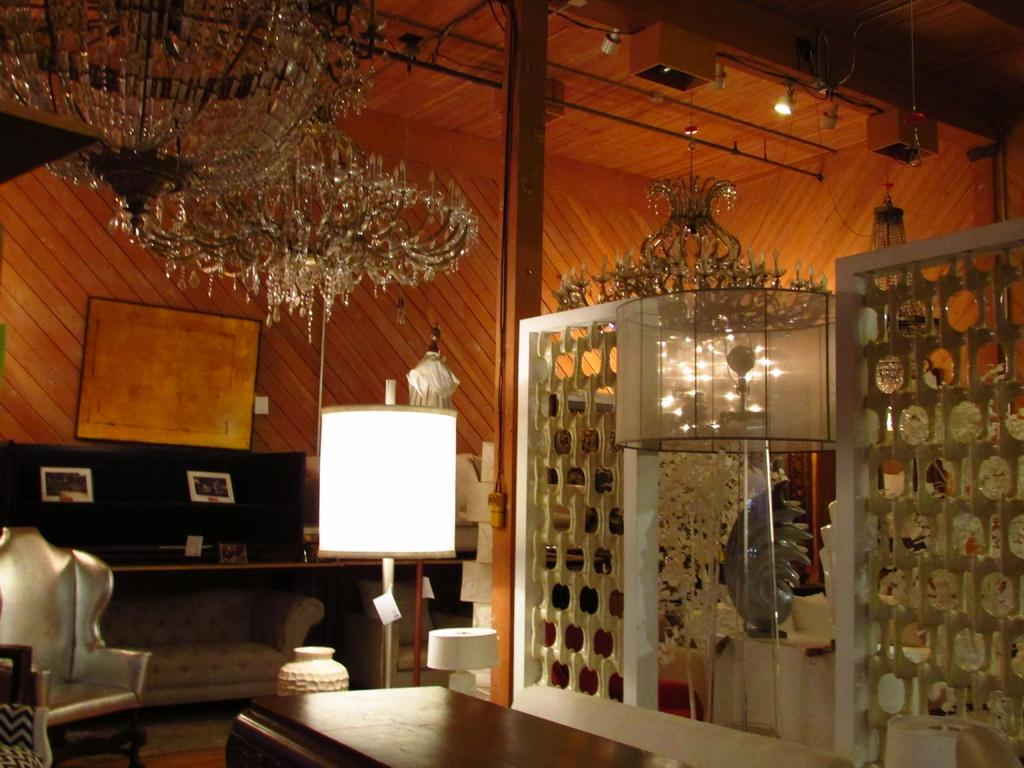What types of objects are present in the image? There are show pieces in the image. What else can be seen in the image besides the show pieces? There are lights in the image. What type of wax is used to create the show pieces in the image? There is no information about wax being used to create the show pieces in the image. 